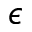<formula> <loc_0><loc_0><loc_500><loc_500>\epsilon</formula> 